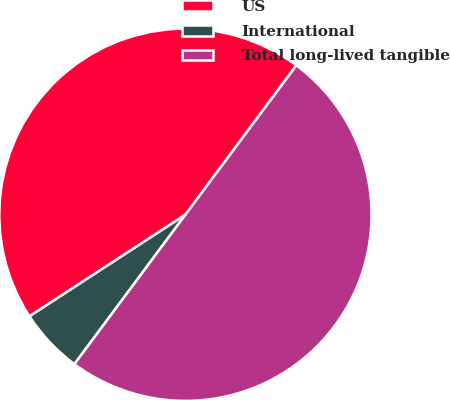Convert chart to OTSL. <chart><loc_0><loc_0><loc_500><loc_500><pie_chart><fcel>US<fcel>International<fcel>Total long-lived tangible<nl><fcel>44.36%<fcel>5.64%<fcel>50.0%<nl></chart> 